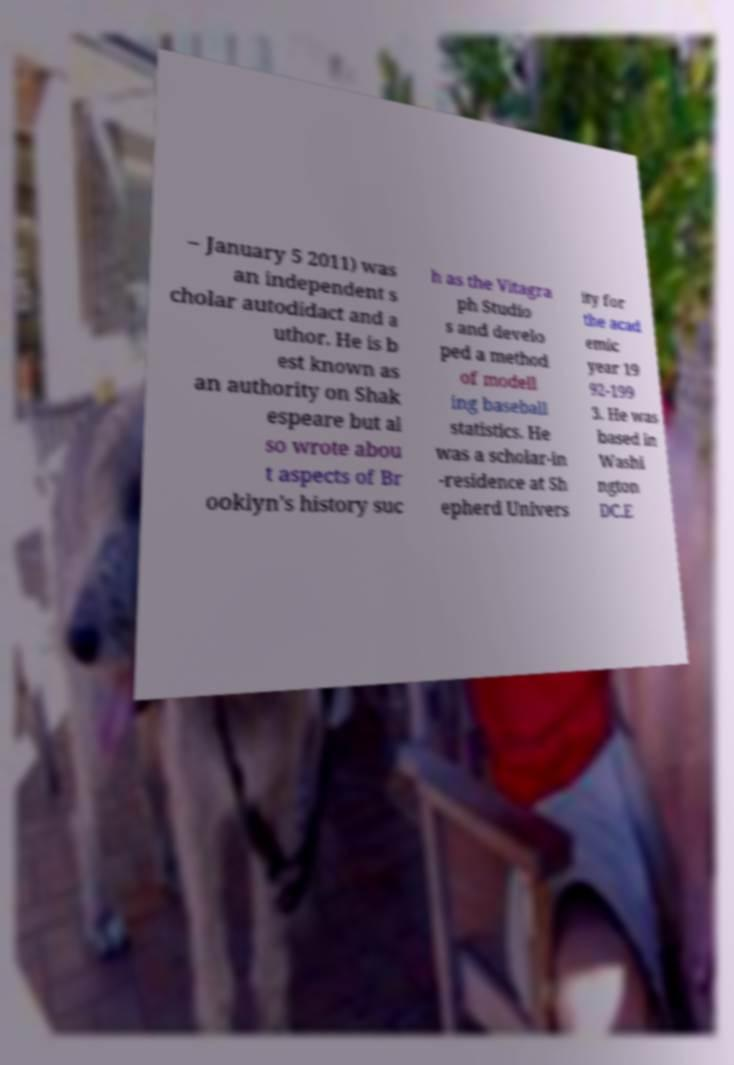Can you read and provide the text displayed in the image?This photo seems to have some interesting text. Can you extract and type it out for me? – January 5 2011) was an independent s cholar autodidact and a uthor. He is b est known as an authority on Shak espeare but al so wrote abou t aspects of Br ooklyn's history suc h as the Vitagra ph Studio s and develo ped a method of modell ing baseball statistics. He was a scholar-in -residence at Sh epherd Univers ity for the acad emic year 19 92-199 3. He was based in Washi ngton DC.E 